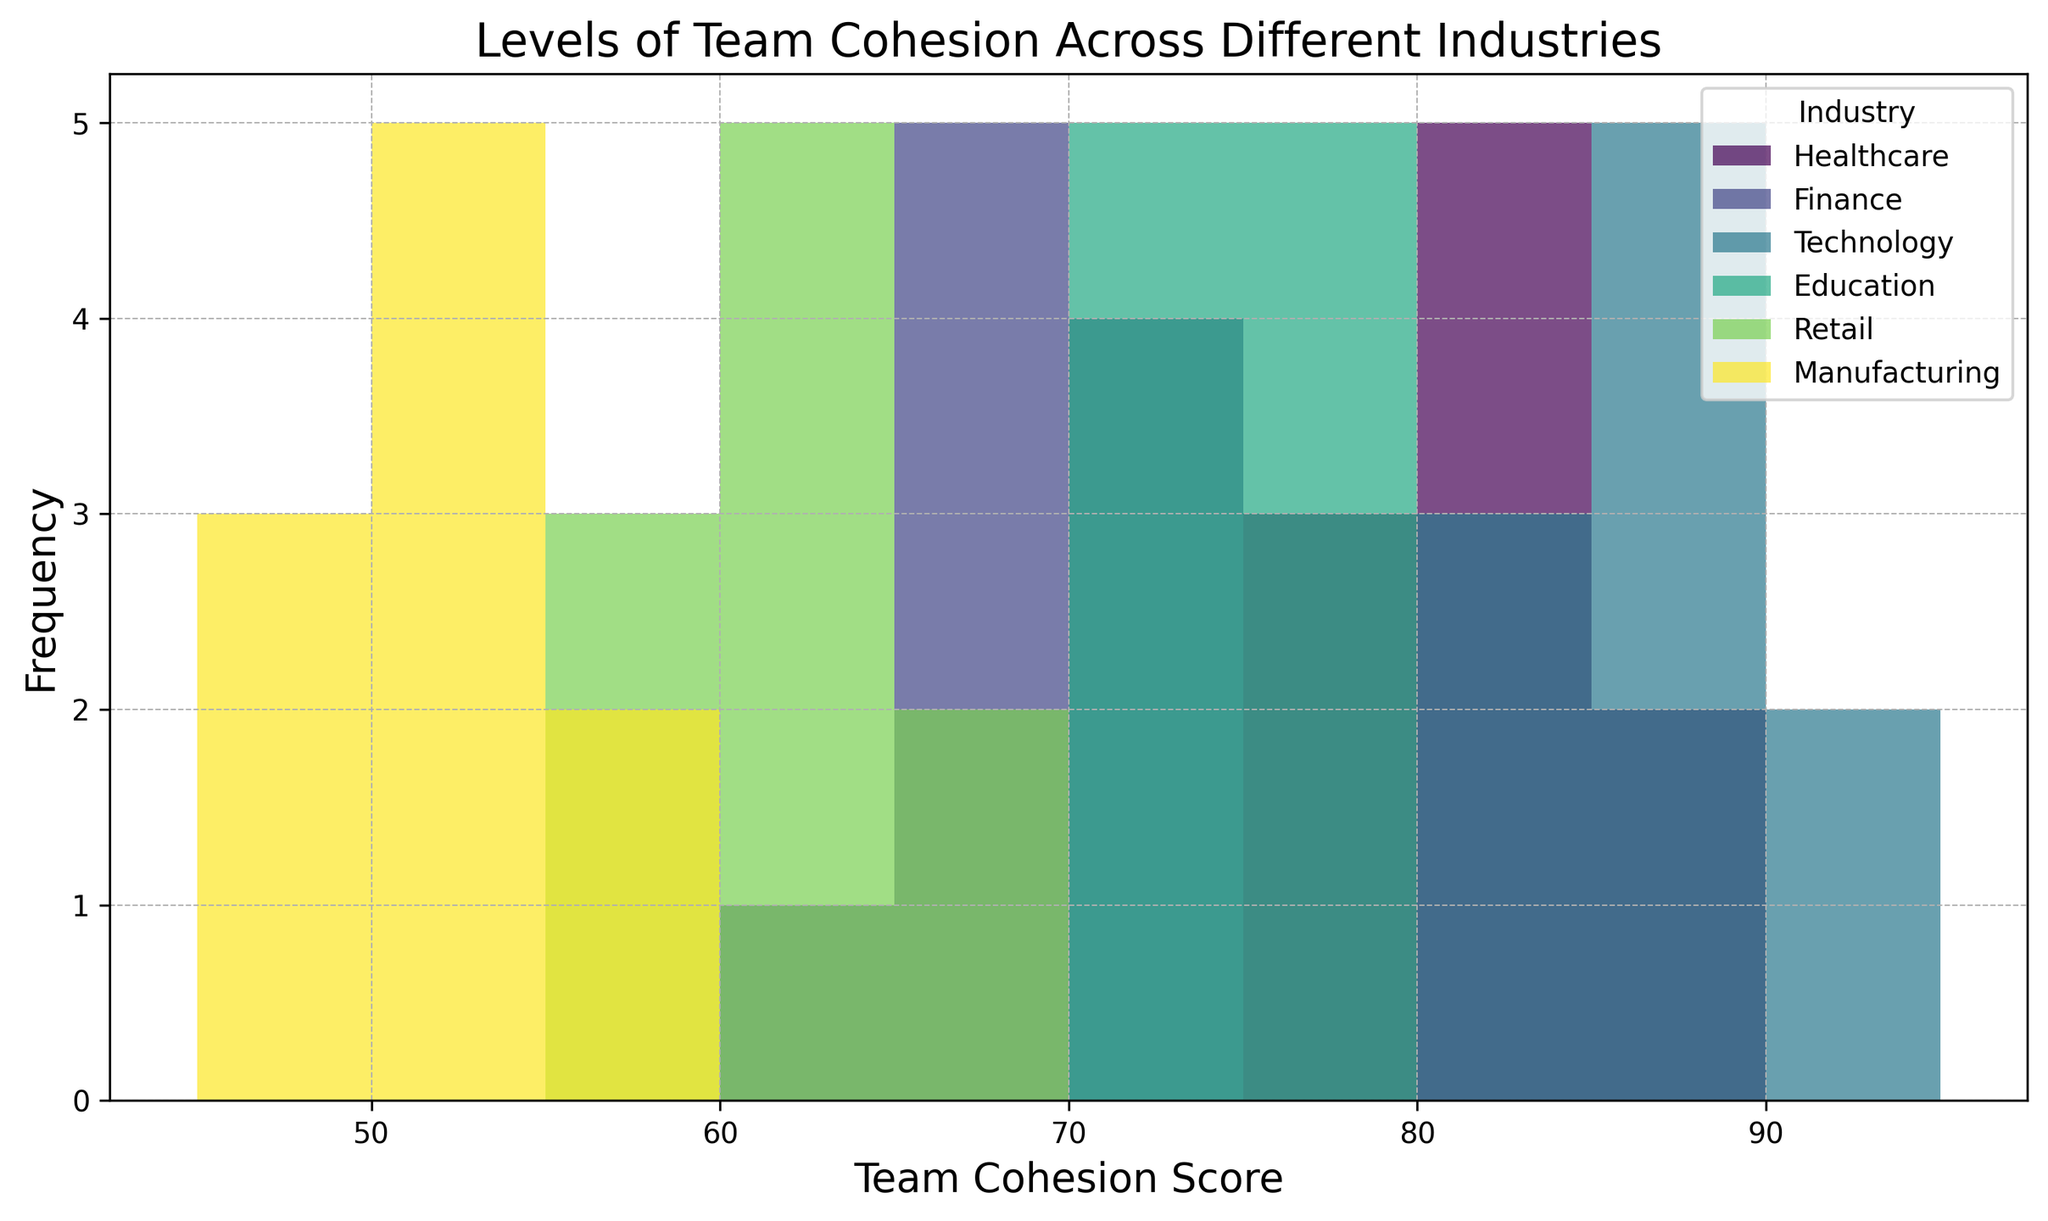What industry shows the highest level of team cohesion? By looking at the histogram, we identify which industry has the tallest bar positioned at the highest team cohesion score. Technology has the highest cohesion scores with the tallest bars around the 85-91 range.
Answer: Technology Which industry has the greatest range of team cohesion scores? To determine the range, we observe the spread of data. Retail has scores from 57 to 66, while Manufacturing has scores from 47 to 56. Manufacturing has the widest range of 10 points (47 to 56).
Answer: Manufacturing Which industry is depicted in green? By matching the color depicted in the histogram with the label in the legend, we can identify which industry is assigned green. The industry with the green color is Technology.
Answer: Technology How does the median team cohesion score of Finance compare to that of Healthcare? To find the median score, we look at the central value in each distribution. For Finance, it's around 68-69, while for Healthcare, it's around 81-82. Healthcare's median score is higher than Finance's.
Answer: Healthcare's median is higher What is the most common team cohesion score range in Retail? By identifying the tallest bars in Retail's section, we see which range appears most frequently. The tallest bars for Retail are in the 60-65 score range.
Answer: 60-65 Which industry has the lowest level of team cohesion? We look for the industry with bars positioned at the lowest score range on the x-axis. Manufacturing has scores ranging from 47 to 56, the lowest among all industries.
Answer: Manufacturing Are there any overlaps in team cohesion scores between Healthcare and Education? By visually inspecting the histogram, we see if there are common ranges where bars from both Healthcare and Education appear. There is an overlap in the 70-79 score range.
Answer: Yes How does the height of the tallest bar in Healthcare compare to the tallest bar in Education? We compare the heights of the tallest bars in each section. Healthcare's tallest bar is slightly shorter than Education's tallest bar.
Answer: Education's tallest bar is taller What's the average team cohesion score for the Technology industry? To find the average, sum the scores (90, 87, 85, 88, 91, 86, 89, 83, 84, 82) and divide by the number of scores (10). The sum is 865, so the average is 865/10 = 86.5.
Answer: 86.5 Do Healthcare and Technology industries have any score range overlaps? By observing the histogram, we see if any score ranges share bars from both industries. Both industries overlap in the 80-85 score range.
Answer: Yes 